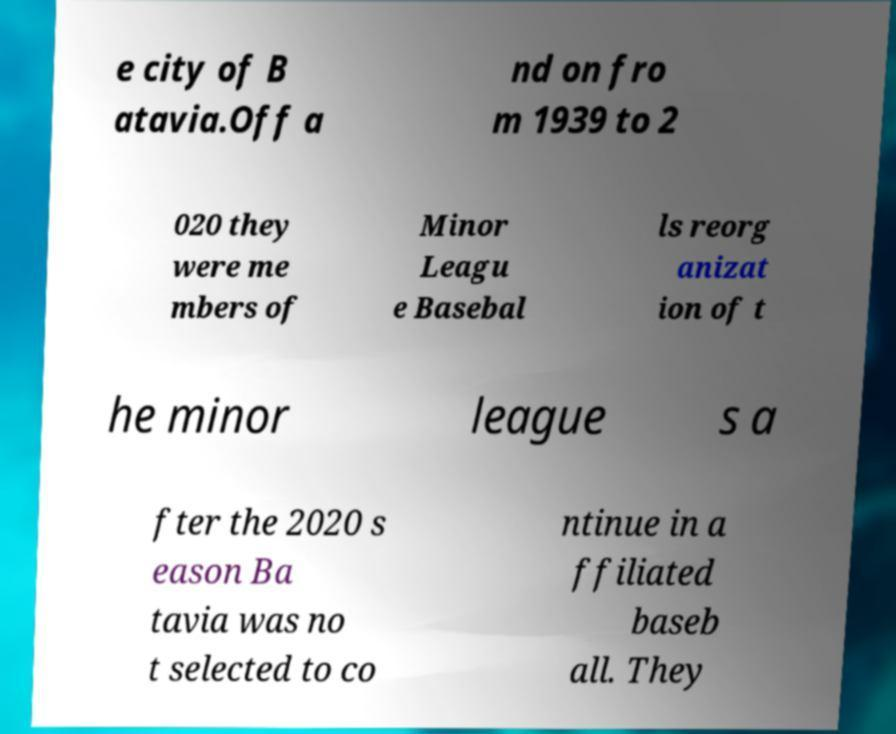Can you accurately transcribe the text from the provided image for me? e city of B atavia.Off a nd on fro m 1939 to 2 020 they were me mbers of Minor Leagu e Basebal ls reorg anizat ion of t he minor league s a fter the 2020 s eason Ba tavia was no t selected to co ntinue in a ffiliated baseb all. They 